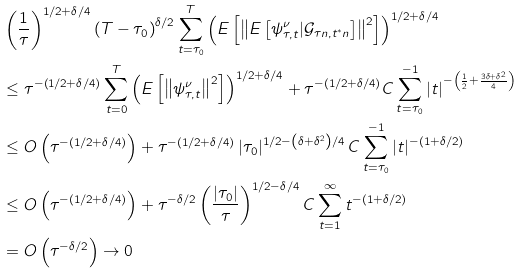<formula> <loc_0><loc_0><loc_500><loc_500>& \left ( \frac { 1 } { \tau } \right ) ^ { 1 / 2 + \delta / 4 } \left ( T - \tau _ { 0 } \right ) ^ { \delta / 2 } \sum _ { t = \tau _ { 0 } } ^ { T } \left ( E \left [ \left \| E \left [ \psi _ { \tau , t } ^ { \nu } | \mathcal { G } _ { \tau n , t ^ { \ast } n } \right ] \right \| ^ { 2 } \right ] \right ) ^ { 1 / 2 + \delta / 4 } \\ & \leq \tau ^ { - \left ( 1 / 2 + \delta / 4 \right ) } \sum _ { t = 0 } ^ { T } \left ( E \left [ \left \| \psi _ { \tau , t } ^ { \nu } \right \| ^ { 2 } \right ] \right ) ^ { 1 / 2 + \delta / 4 } + \tau ^ { - \left ( 1 / 2 + \delta / 4 \right ) } C \sum _ { t = \tau _ { 0 } } ^ { - 1 } \left | t \right | ^ { - \left ( \frac { 1 } { 2 } + \frac { 3 \delta + \delta ^ { 2 } } { 4 } \right ) } \\ & \leq O \left ( \tau ^ { - \left ( 1 / 2 + \delta / 4 \right ) } \right ) + \tau ^ { - \left ( 1 / 2 + \delta / 4 \right ) } \left | \tau _ { 0 } \right | ^ { 1 / 2 - \left ( \delta + \delta ^ { 2 } \right ) / 4 } C \sum _ { t = \tau _ { 0 } } ^ { - 1 } \left | t \right | ^ { - \left ( 1 + \delta / 2 \right ) } \\ & \leq O \left ( \tau ^ { - \left ( 1 / 2 + \delta / 4 \right ) } \right ) + \tau ^ { - \delta / 2 } \left ( \frac { \left | \tau _ { 0 } \right | } { \tau } \right ) ^ { 1 / 2 - \delta / 4 } C \sum _ { t = 1 } ^ { \infty } t ^ { - \left ( 1 + \delta / 2 \right ) } \\ & = O \left ( \tau ^ { - \delta / 2 } \right ) \rightarrow 0</formula> 